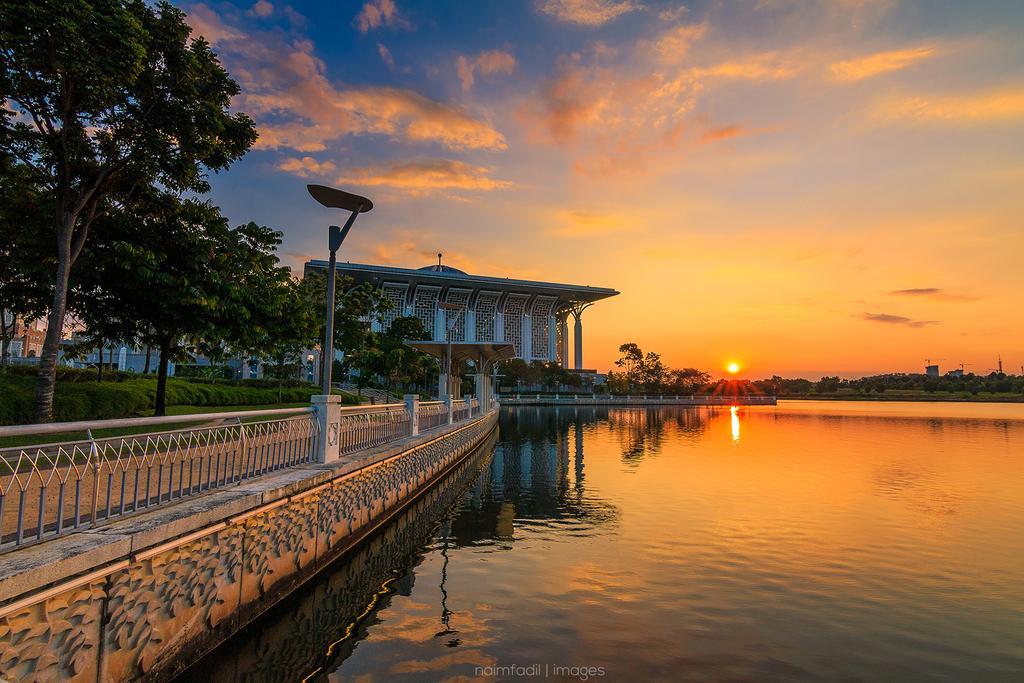In one or two sentences, can you explain what this image depicts? In this image there is a lake, on the right side there is fencing, trees, in the background there is a house and a beautiful sunset in the sky. 